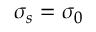<formula> <loc_0><loc_0><loc_500><loc_500>\sigma _ { s } = \sigma _ { 0 }</formula> 